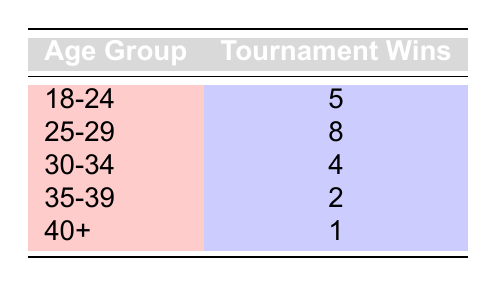What age group has the highest number of tournament wins? The table shows that the age group 25-29 has the most tournament wins, with a total of 8 wins.
Answer: 25-29 How many tournament wins does the age group 18-24 have? According to the table, the age group 18-24 has 5 tournament wins listed.
Answer: 5 What is the total number of tournament wins for players aged 30 and older? The total tournament wins for age groups 30-34, 35-39, and 40+ are 4, 2, and 1 respectively. Adding these together: 4 + 2 + 1 = 7.
Answer: 7 Is it true that players aged 40 and older have more tournament wins than players aged 35-39? From the table, players aged 40+ have 1 tournament win, while those aged 35-39 have 2 tournament wins, indicating that it is false.
Answer: No What is the average number of tournament wins for the age group 25-29 compared to the age group 35-39? The age group 25-29 has 8 tournament wins, and the age group 35-39 has 2. The average is calculated by taking the sum of wins for both groups (8 + 2 = 10) and dividing by 2, which results in an average of 5.
Answer: 5 What is the difference in tournament wins between the age groups 18-24 and 30-34? The age group 18-24 has 5 tournament wins and the age group 30-34 has 4. The difference is calculated as 5 - 4 = 1.
Answer: 1 Which age group has the lowest number of tournament wins? By checking the table, the age group 40+ shows the least number of tournament wins, with only 1 win.
Answer: 40+ If you combine the tournament wins of the 18-24 and 25-29 age groups, how does it compare to the combined wins of the 35-39 and 40+ age groups? The combined wins for 18-24 (5) and 25-29 (8) total 13. The combined wins for 35-39 (2) and 40+ (1) total 3. Comparing these, 13 is significantly higher than 3.
Answer: 13 > 3 